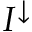Convert formula to latex. <formula><loc_0><loc_0><loc_500><loc_500>I ^ { \downarrow }</formula> 